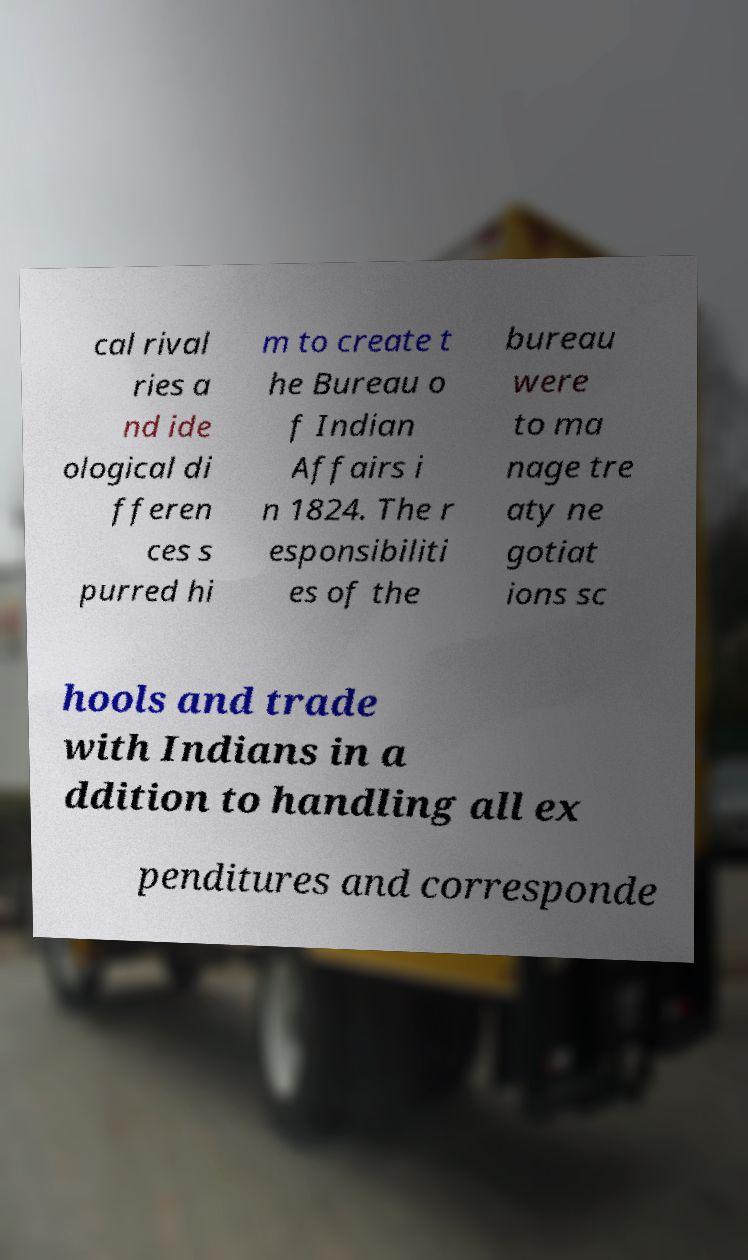What messages or text are displayed in this image? I need them in a readable, typed format. cal rival ries a nd ide ological di fferen ces s purred hi m to create t he Bureau o f Indian Affairs i n 1824. The r esponsibiliti es of the bureau were to ma nage tre aty ne gotiat ions sc hools and trade with Indians in a ddition to handling all ex penditures and corresponde 